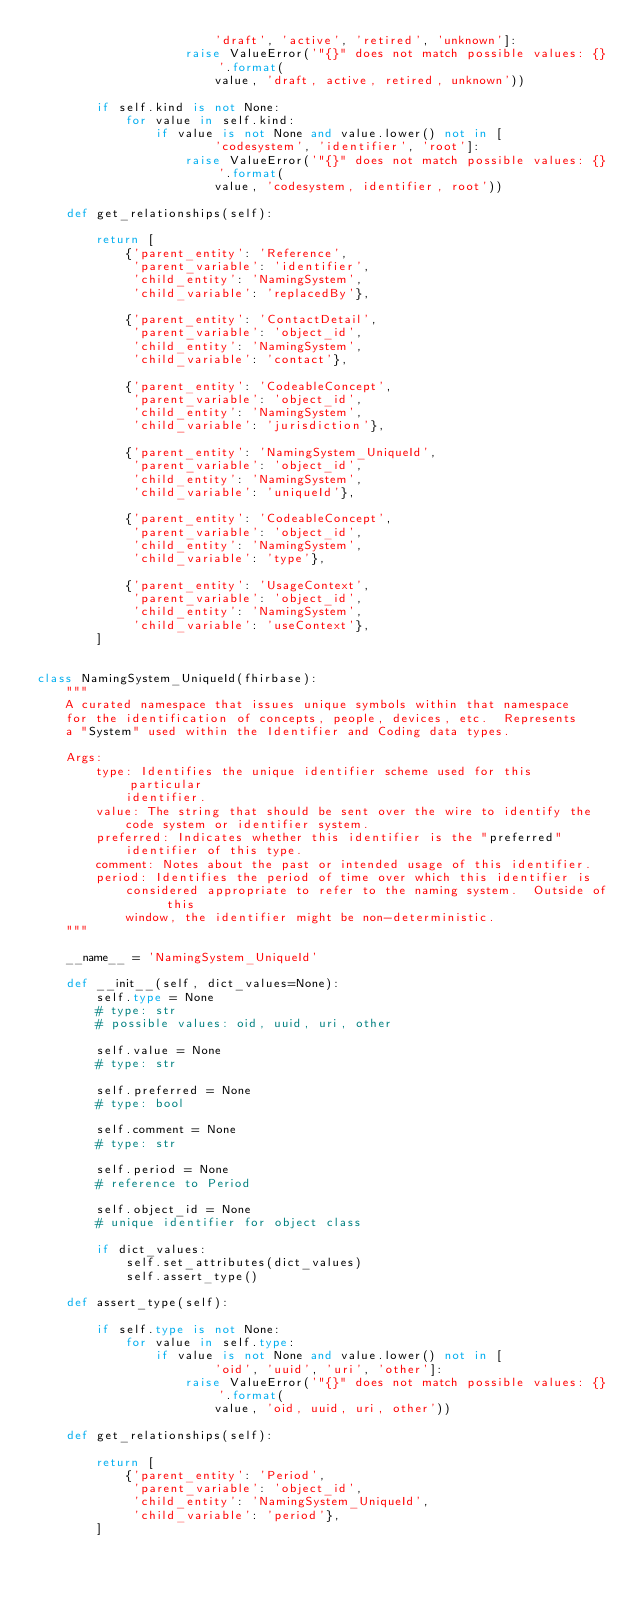<code> <loc_0><loc_0><loc_500><loc_500><_Python_>                        'draft', 'active', 'retired', 'unknown']:
                    raise ValueError('"{}" does not match possible values: {}'.format(
                        value, 'draft, active, retired, unknown'))

        if self.kind is not None:
            for value in self.kind:
                if value is not None and value.lower() not in [
                        'codesystem', 'identifier', 'root']:
                    raise ValueError('"{}" does not match possible values: {}'.format(
                        value, 'codesystem, identifier, root'))

    def get_relationships(self):

        return [
            {'parent_entity': 'Reference',
             'parent_variable': 'identifier',
             'child_entity': 'NamingSystem',
             'child_variable': 'replacedBy'},

            {'parent_entity': 'ContactDetail',
             'parent_variable': 'object_id',
             'child_entity': 'NamingSystem',
             'child_variable': 'contact'},

            {'parent_entity': 'CodeableConcept',
             'parent_variable': 'object_id',
             'child_entity': 'NamingSystem',
             'child_variable': 'jurisdiction'},

            {'parent_entity': 'NamingSystem_UniqueId',
             'parent_variable': 'object_id',
             'child_entity': 'NamingSystem',
             'child_variable': 'uniqueId'},

            {'parent_entity': 'CodeableConcept',
             'parent_variable': 'object_id',
             'child_entity': 'NamingSystem',
             'child_variable': 'type'},

            {'parent_entity': 'UsageContext',
             'parent_variable': 'object_id',
             'child_entity': 'NamingSystem',
             'child_variable': 'useContext'},
        ]


class NamingSystem_UniqueId(fhirbase):
    """
    A curated namespace that issues unique symbols within that namespace
    for the identification of concepts, people, devices, etc.  Represents
    a "System" used within the Identifier and Coding data types.

    Args:
        type: Identifies the unique identifier scheme used for this particular
            identifier.
        value: The string that should be sent over the wire to identify the
            code system or identifier system.
        preferred: Indicates whether this identifier is the "preferred"
            identifier of this type.
        comment: Notes about the past or intended usage of this identifier.
        period: Identifies the period of time over which this identifier is
            considered appropriate to refer to the naming system.  Outside of this
            window, the identifier might be non-deterministic.
    """

    __name__ = 'NamingSystem_UniqueId'

    def __init__(self, dict_values=None):
        self.type = None
        # type: str
        # possible values: oid, uuid, uri, other

        self.value = None
        # type: str

        self.preferred = None
        # type: bool

        self.comment = None
        # type: str

        self.period = None
        # reference to Period

        self.object_id = None
        # unique identifier for object class

        if dict_values:
            self.set_attributes(dict_values)
            self.assert_type()

    def assert_type(self):

        if self.type is not None:
            for value in self.type:
                if value is not None and value.lower() not in [
                        'oid', 'uuid', 'uri', 'other']:
                    raise ValueError('"{}" does not match possible values: {}'.format(
                        value, 'oid, uuid, uri, other'))

    def get_relationships(self):

        return [
            {'parent_entity': 'Period',
             'parent_variable': 'object_id',
             'child_entity': 'NamingSystem_UniqueId',
             'child_variable': 'period'},
        ]
</code> 